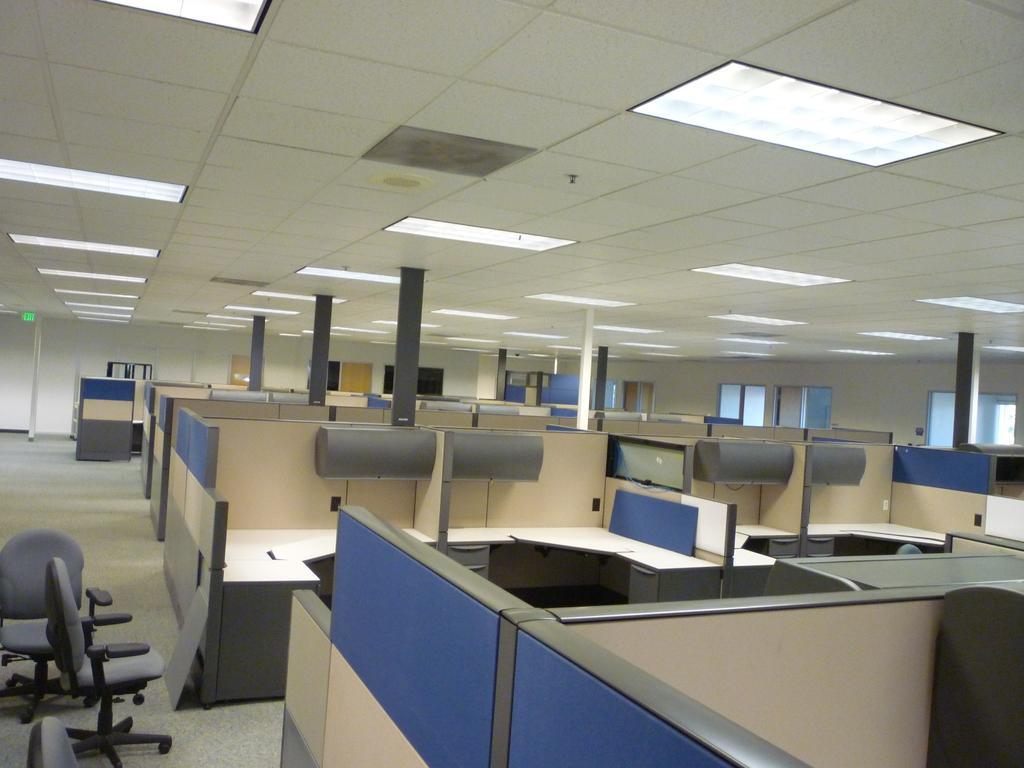How would you summarize this image in a sentence or two? This is a picture of an office. On the left there are chairs. In the foreground there are shelves and desks. At the top it is ceiling, there are lights to the ceiling. On the right, in the background there are windows. 